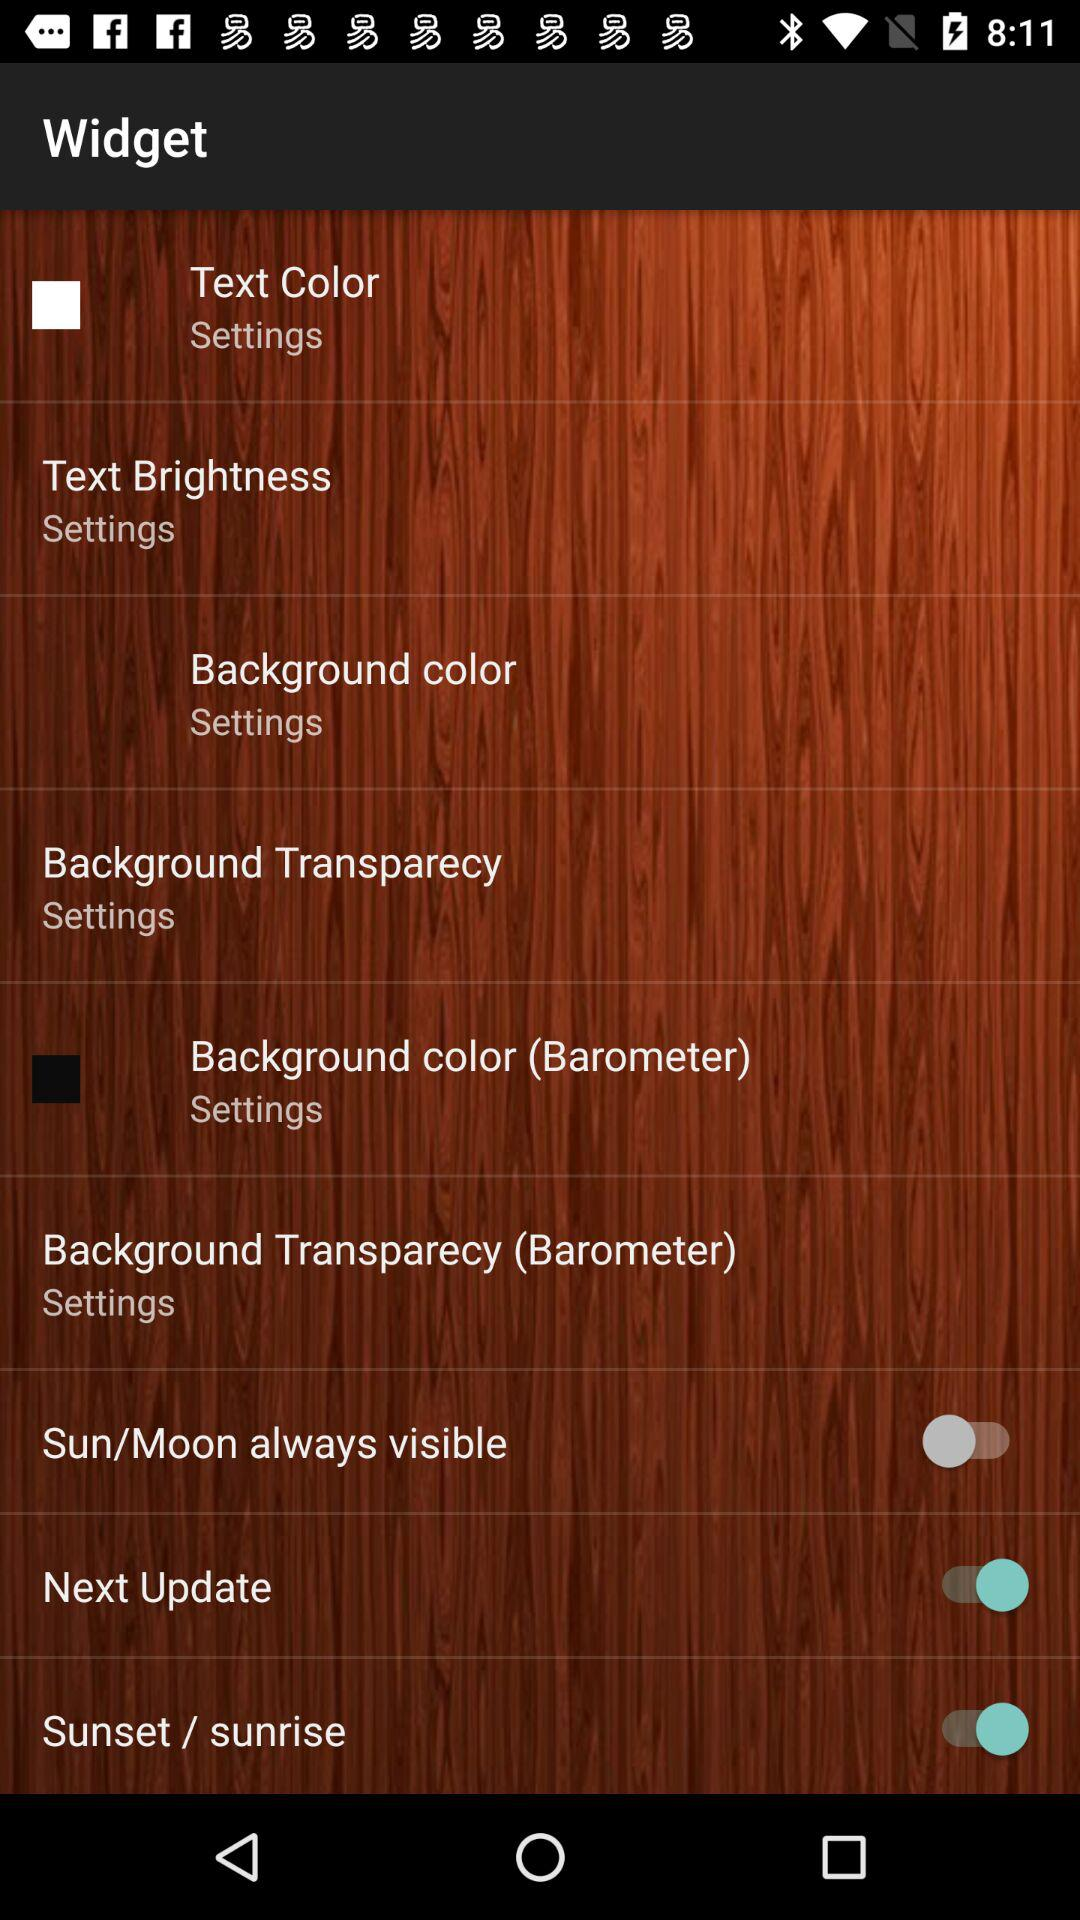What is the status of the "Next Update"? The status is "on". 